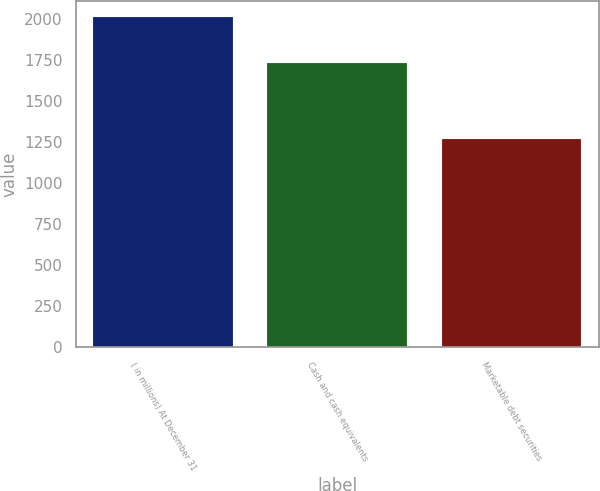<chart> <loc_0><loc_0><loc_500><loc_500><bar_chart><fcel>( in millions) At December 31<fcel>Cash and cash equivalents<fcel>Marketable debt securities<nl><fcel>2014<fcel>1737.6<fcel>1272<nl></chart> 